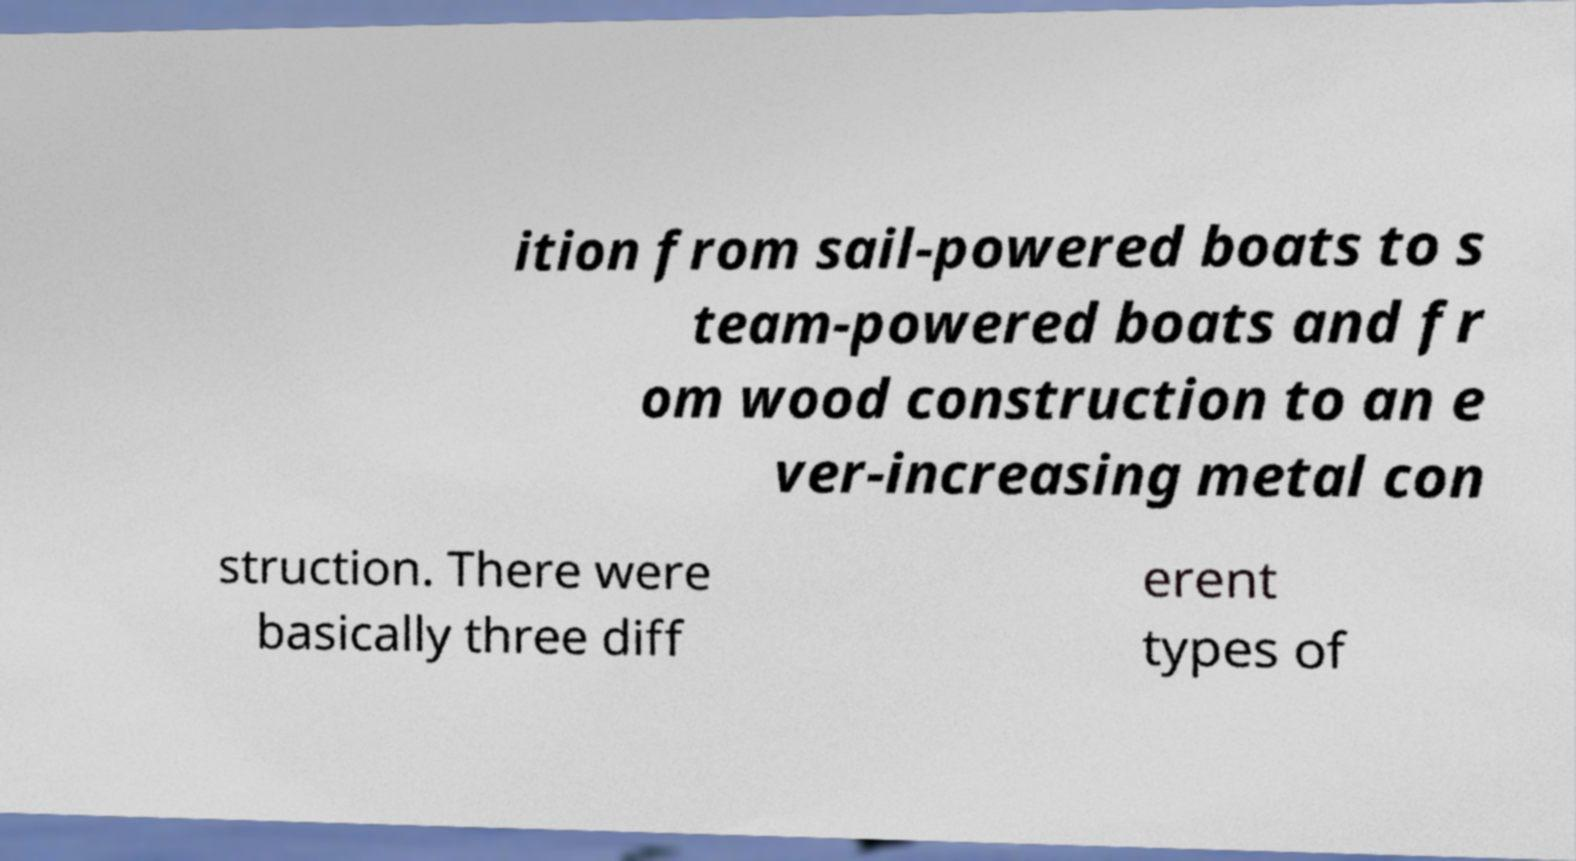Could you assist in decoding the text presented in this image and type it out clearly? ition from sail-powered boats to s team-powered boats and fr om wood construction to an e ver-increasing metal con struction. There were basically three diff erent types of 